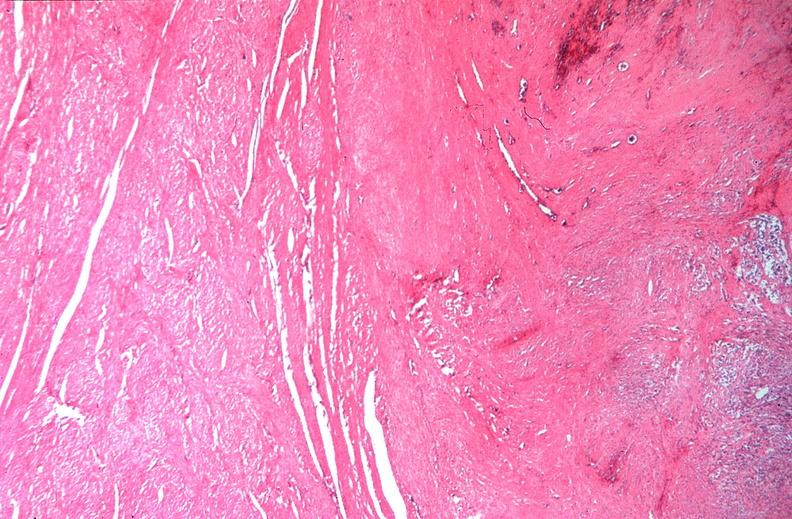what does this image show?
Answer the question using a single word or phrase. Uterus 